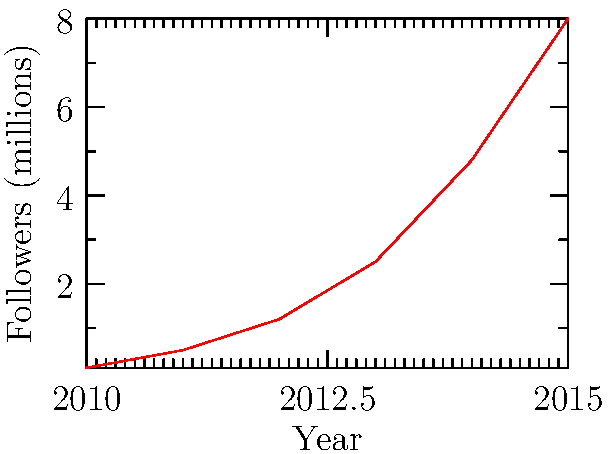The graph shows the social media growth of a retired hip-hop artist from 2010 to 2015. What was the approximate increase in followers (in millions) between 2013 and 2014? To find the increase in followers between 2013 and 2014:

1. Locate the data points for 2013 and 2014 on the graph.
2. Read the corresponding y-axis values (followers in millions):
   - 2013: approximately 2.5 million followers
   - 2014: approximately 4.8 million followers
3. Calculate the difference:
   $4.8 - 2.5 = 2.3$ million followers

The increase in followers from 2013 to 2014 was approximately 2.3 million.
Answer: 2.3 million 